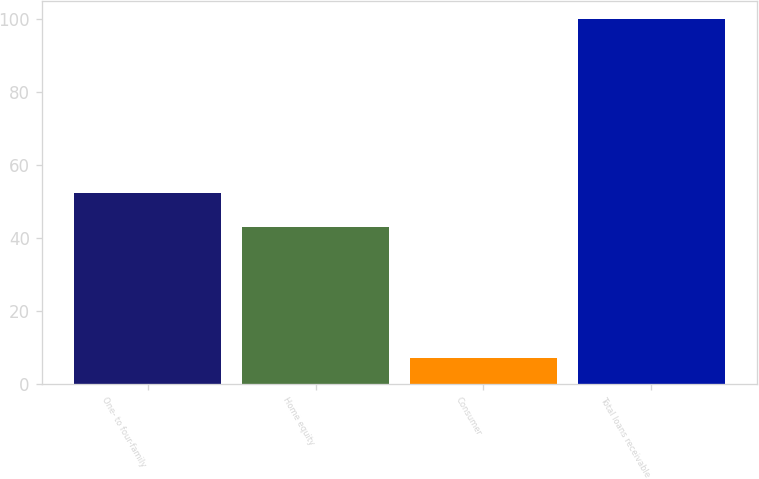Convert chart to OTSL. <chart><loc_0><loc_0><loc_500><loc_500><bar_chart><fcel>One- to four-family<fcel>Home equity<fcel>Consumer<fcel>Total loans receivable<nl><fcel>52.3<fcel>43<fcel>7<fcel>100<nl></chart> 